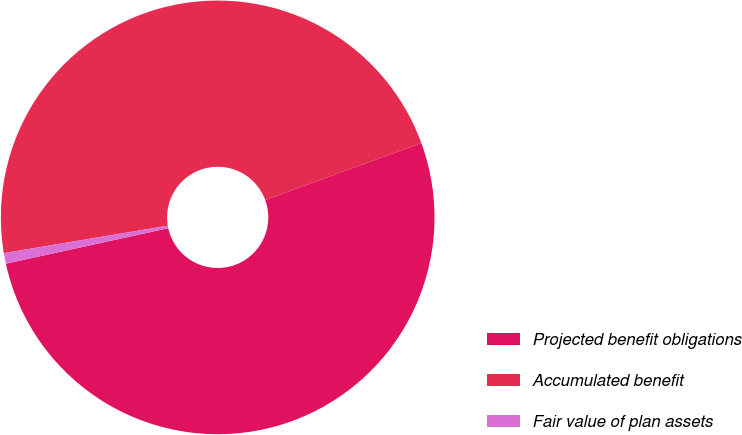Convert chart to OTSL. <chart><loc_0><loc_0><loc_500><loc_500><pie_chart><fcel>Projected benefit obligations<fcel>Accumulated benefit<fcel>Fair value of plan assets<nl><fcel>52.14%<fcel>47.06%<fcel>0.79%<nl></chart> 